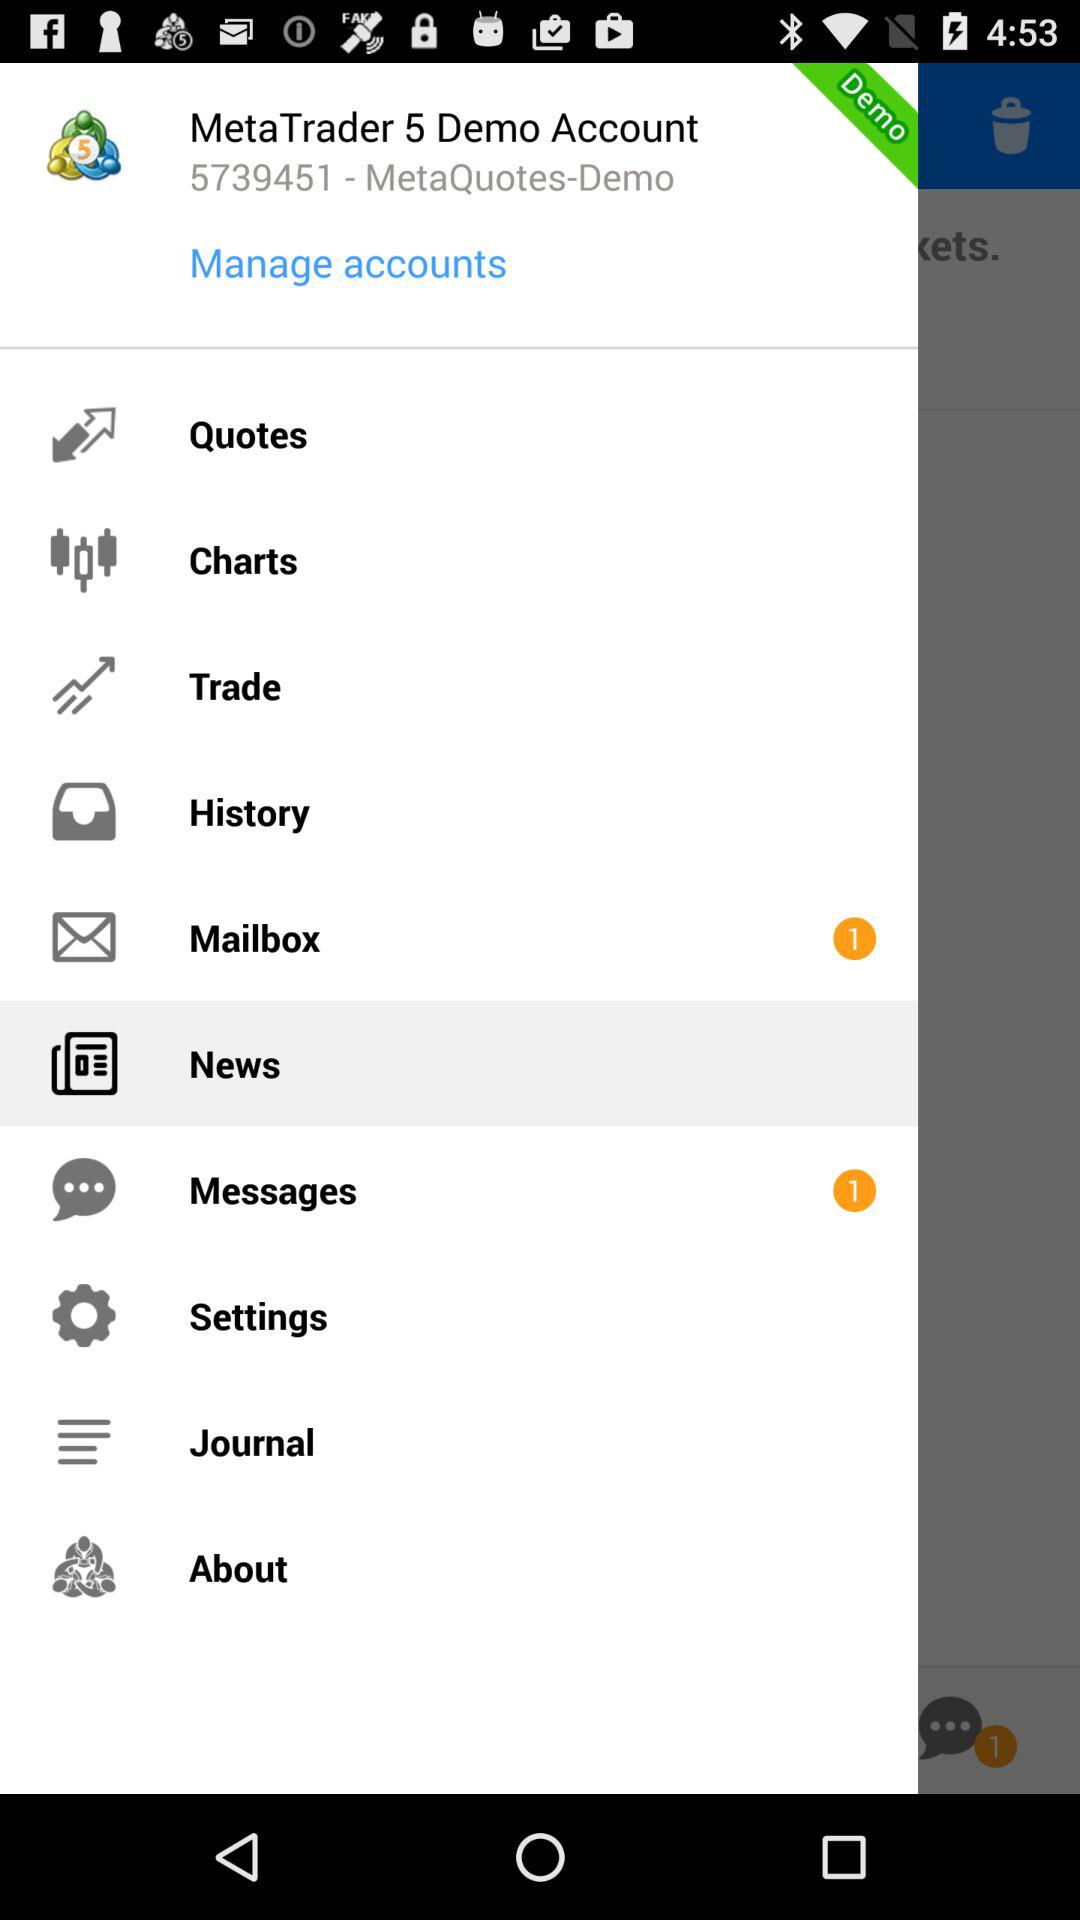What is in the history?
When the provided information is insufficient, respond with <no answer>. <no answer> 